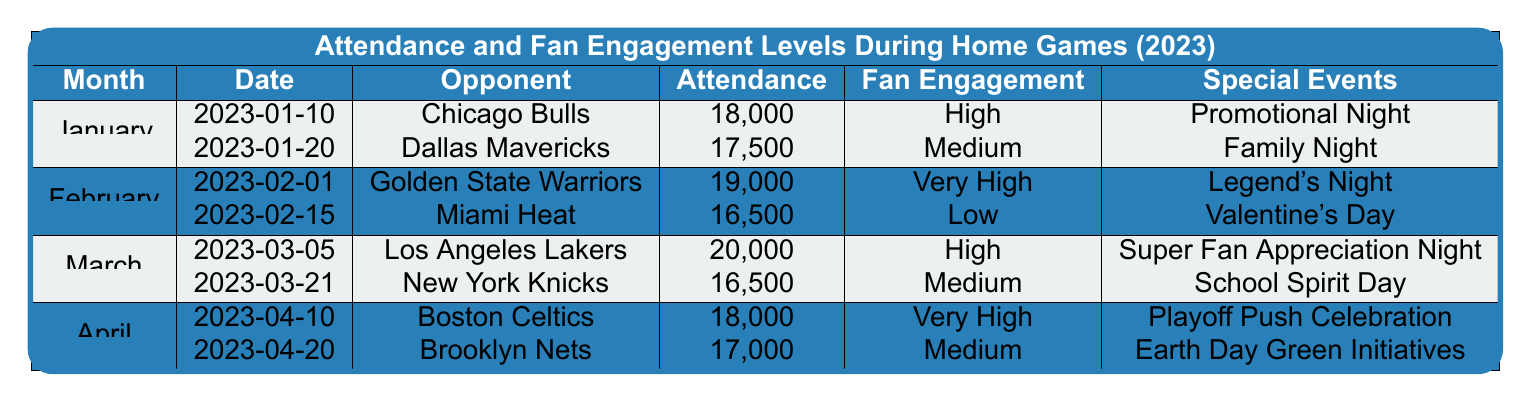What was the attendance at the game against the Los Angeles Lakers? The game against the Los Angeles Lakers took place on March 5, 2023, and the attendance was 20,000, as mentioned in the table.
Answer: 20,000 How many games were played in April? The table shows two home games played in April: one against the Boston Celtics and the other against the Brooklyn Nets.
Answer: 2 What is the fan engagement level for the game on February 1, 2023? The game on February 1, 2023, against the Golden State Warriors had a fan engagement level labeled as "Very High."
Answer: Very High Which month had the highest attendance figure? By examining the attendance figures, March had the highest number with 20,000 attendees for the game against the Los Angeles Lakers.
Answer: March What was the average attendance for home games in January 2023? In January, the attendance figures were 18,000 and 17,500. Adding them gives 35,500. Dividing by 2 (the number of games) gives an average attendance of 17,750.
Answer: 17,750 Did any game in February have a fan engagement level of "Very High"? Yes, the game against the Golden State Warriors on February 1, 2023, had a fan engagement level of "Very High."
Answer: Yes What special event took place during the game against the Chicago Bulls? The game against the Chicago Bulls on January 10, 2023, featured "Promotional Night" as the special event.
Answer: Promotional Night How does the attendance of the game on April 10 compare to that of the game on February 15? The game on April 10 had an attendance of 18,000, while the game on February 15 had an attendance of 16,500. The game on April 10 had 1,500 more attendees.
Answer: 1,500 more Which month experienced the lowest fan engagement level? February had the lowest fan engagement level during the game against the Miami Heat, which was rated as "Low."
Answer: February How many total attendees were there across all home games in March? The attendance for March was 20,000 for the game on March 5 and 16,500 for the game on March 21, totaling 36,500 attendees.
Answer: 36,500 